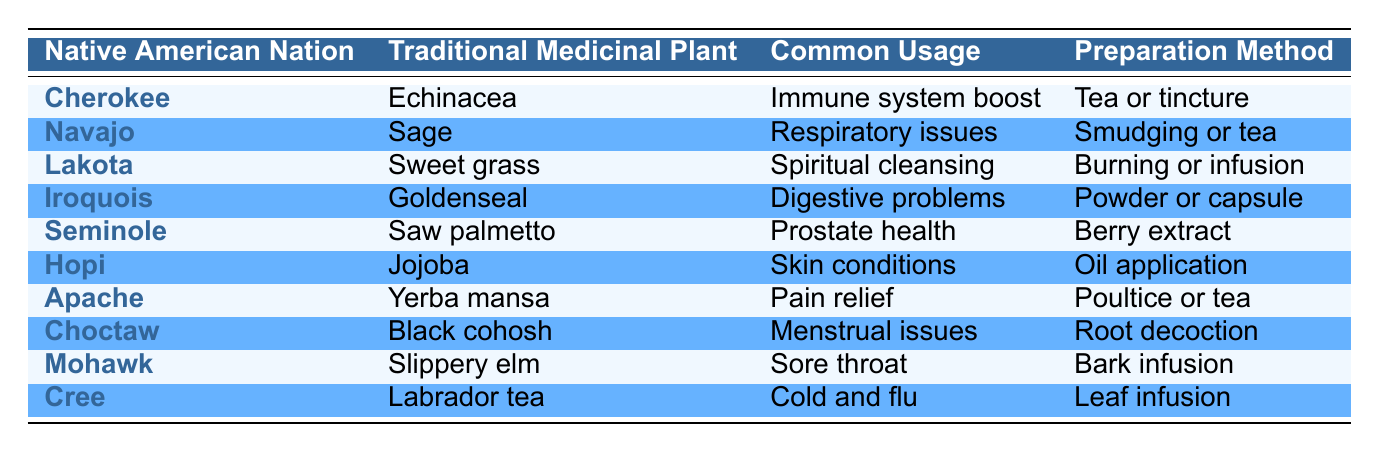What traditional medicinal plant is used by the Cherokee nation? According to the table, the plant used by the Cherokee nation is Echinacea.
Answer: Echinacea Which Native American nation uses Sage for respiratory issues? The table indicates that the Navajo nation uses Sage for respiratory issues.
Answer: Navajo What preparation method is used for Goldenseal by the Iroquois? The table specifies that the Iroquois prepare Goldenseal in powder or capsule form.
Answer: Powder or capsule Does the Hopi nation use any plant for pain relief? According to the table, the Hopi nation does not use any plant for pain relief; it is the Apache nation that uses Yerba mansa for that purpose.
Answer: No Count how many nations listed use plants for digestive problems. From the table, only the Iroquois nation uses a plant for digestive problems (Goldenseal), so the total count is 1.
Answer: 1 What is the most common usage for Slippery elm? The table reveals that Slippery elm is used for sore throat.
Answer: Sore throat Name two plants commonly used for skin conditions and their associated nations. The Hopi nation uses Jojoba for skin conditions while no other nation in the table lists plants specifically for skin conditions. Thus, the only plant and nation are Jojoba by the Hopi.
Answer: Jojoba, Hopi What is the common usage for Black cohosh and which nation uses it? The table states that Black cohosh is used for menstrual issues by the Choctaw nation.
Answer: Menstrual issues, Choctaw Is there any plant listed that is used for immune system boost? Yes, the table shows that Echinacea, used by the Cherokee nation, is associated with immune system boost.
Answer: Yes Which Native American nation has a preparation method that includes burning? The Lakota nation is noted in the table as using the burning method for their traditional medicinal plant, Sweet grass.
Answer: Lakota 